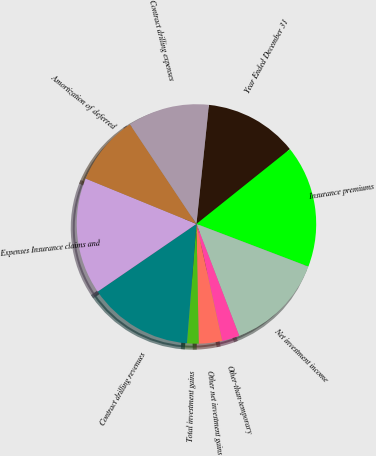Convert chart. <chart><loc_0><loc_0><loc_500><loc_500><pie_chart><fcel>Year Ended December 31<fcel>Insurance premiums<fcel>Net investment income<fcel>Other-than-temporary<fcel>Other net investment gains<fcel>Total investment gains<fcel>Contract drilling revenues<fcel>Expenses Insurance claims and<fcel>Amortization of deferred<fcel>Contract drilling expenses<nl><fcel>12.6%<fcel>16.54%<fcel>13.39%<fcel>2.36%<fcel>3.15%<fcel>1.57%<fcel>14.17%<fcel>15.75%<fcel>9.45%<fcel>11.02%<nl></chart> 